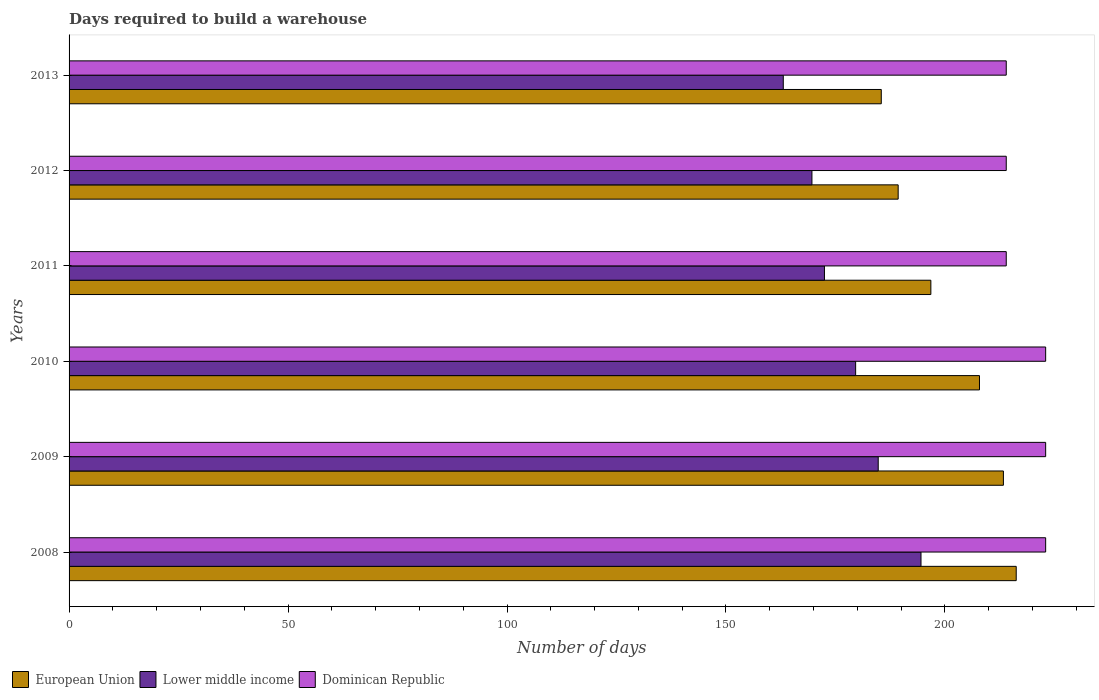How many different coloured bars are there?
Give a very brief answer. 3. In how many cases, is the number of bars for a given year not equal to the number of legend labels?
Make the answer very short. 0. What is the days required to build a warehouse in in European Union in 2011?
Your response must be concise. 196.79. Across all years, what is the maximum days required to build a warehouse in in Dominican Republic?
Make the answer very short. 223. Across all years, what is the minimum days required to build a warehouse in in Dominican Republic?
Ensure brevity in your answer.  214. In which year was the days required to build a warehouse in in Dominican Republic maximum?
Your answer should be very brief. 2008. What is the total days required to build a warehouse in in Lower middle income in the graph?
Keep it short and to the point. 1064.12. What is the difference between the days required to build a warehouse in in Dominican Republic in 2010 and that in 2012?
Your answer should be compact. 9. What is the difference between the days required to build a warehouse in in Dominican Republic in 2009 and the days required to build a warehouse in in Lower middle income in 2008?
Provide a short and direct response. 28.47. What is the average days required to build a warehouse in in Dominican Republic per year?
Offer a very short reply. 218.5. In the year 2009, what is the difference between the days required to build a warehouse in in Dominican Republic and days required to build a warehouse in in European Union?
Your answer should be compact. 9.65. What is the ratio of the days required to build a warehouse in in Dominican Republic in 2008 to that in 2010?
Offer a very short reply. 1. What is the difference between the highest and the second highest days required to build a warehouse in in European Union?
Your answer should be compact. 2.93. What is the difference between the highest and the lowest days required to build a warehouse in in European Union?
Provide a short and direct response. 30.81. Is the sum of the days required to build a warehouse in in European Union in 2010 and 2011 greater than the maximum days required to build a warehouse in in Lower middle income across all years?
Your answer should be very brief. Yes. What does the 2nd bar from the top in 2009 represents?
Offer a very short reply. Lower middle income. What does the 1st bar from the bottom in 2012 represents?
Your response must be concise. European Union. Is it the case that in every year, the sum of the days required to build a warehouse in in European Union and days required to build a warehouse in in Dominican Republic is greater than the days required to build a warehouse in in Lower middle income?
Make the answer very short. Yes. How many bars are there?
Provide a succinct answer. 18. Are all the bars in the graph horizontal?
Ensure brevity in your answer.  Yes. What is the difference between two consecutive major ticks on the X-axis?
Provide a succinct answer. 50. Where does the legend appear in the graph?
Ensure brevity in your answer.  Bottom left. How are the legend labels stacked?
Ensure brevity in your answer.  Horizontal. What is the title of the graph?
Make the answer very short. Days required to build a warehouse. Does "Cote d'Ivoire" appear as one of the legend labels in the graph?
Your answer should be compact. No. What is the label or title of the X-axis?
Ensure brevity in your answer.  Number of days. What is the Number of days of European Union in 2008?
Your response must be concise. 216.28. What is the Number of days in Lower middle income in 2008?
Keep it short and to the point. 194.53. What is the Number of days of Dominican Republic in 2008?
Give a very brief answer. 223. What is the Number of days in European Union in 2009?
Your response must be concise. 213.35. What is the Number of days of Lower middle income in 2009?
Make the answer very short. 184.77. What is the Number of days of Dominican Republic in 2009?
Ensure brevity in your answer.  223. What is the Number of days in European Union in 2010?
Make the answer very short. 207.89. What is the Number of days of Lower middle income in 2010?
Offer a terse response. 179.61. What is the Number of days in Dominican Republic in 2010?
Give a very brief answer. 223. What is the Number of days of European Union in 2011?
Your answer should be very brief. 196.79. What is the Number of days of Lower middle income in 2011?
Your answer should be very brief. 172.49. What is the Number of days in Dominican Republic in 2011?
Offer a terse response. 214. What is the Number of days in European Union in 2012?
Ensure brevity in your answer.  189.32. What is the Number of days in Lower middle income in 2012?
Offer a terse response. 169.63. What is the Number of days in Dominican Republic in 2012?
Your answer should be compact. 214. What is the Number of days in European Union in 2013?
Offer a very short reply. 185.46. What is the Number of days in Lower middle income in 2013?
Offer a very short reply. 163.09. What is the Number of days in Dominican Republic in 2013?
Keep it short and to the point. 214. Across all years, what is the maximum Number of days in European Union?
Your answer should be compact. 216.28. Across all years, what is the maximum Number of days in Lower middle income?
Provide a short and direct response. 194.53. Across all years, what is the maximum Number of days of Dominican Republic?
Your answer should be very brief. 223. Across all years, what is the minimum Number of days of European Union?
Offer a very short reply. 185.46. Across all years, what is the minimum Number of days in Lower middle income?
Keep it short and to the point. 163.09. Across all years, what is the minimum Number of days of Dominican Republic?
Keep it short and to the point. 214. What is the total Number of days of European Union in the graph?
Keep it short and to the point. 1209.09. What is the total Number of days of Lower middle income in the graph?
Make the answer very short. 1064.12. What is the total Number of days in Dominican Republic in the graph?
Provide a succinct answer. 1311. What is the difference between the Number of days of European Union in 2008 and that in 2009?
Give a very brief answer. 2.93. What is the difference between the Number of days of Lower middle income in 2008 and that in 2009?
Offer a very short reply. 9.77. What is the difference between the Number of days in Dominican Republic in 2008 and that in 2009?
Give a very brief answer. 0. What is the difference between the Number of days in European Union in 2008 and that in 2010?
Your answer should be very brief. 8.39. What is the difference between the Number of days in Lower middle income in 2008 and that in 2010?
Keep it short and to the point. 14.92. What is the difference between the Number of days in Dominican Republic in 2008 and that in 2010?
Give a very brief answer. 0. What is the difference between the Number of days of European Union in 2008 and that in 2011?
Provide a succinct answer. 19.49. What is the difference between the Number of days in Lower middle income in 2008 and that in 2011?
Offer a very short reply. 22.05. What is the difference between the Number of days of European Union in 2008 and that in 2012?
Make the answer very short. 26.96. What is the difference between the Number of days in Lower middle income in 2008 and that in 2012?
Your answer should be very brief. 24.9. What is the difference between the Number of days in Dominican Republic in 2008 and that in 2012?
Provide a succinct answer. 9. What is the difference between the Number of days of European Union in 2008 and that in 2013?
Make the answer very short. 30.81. What is the difference between the Number of days of Lower middle income in 2008 and that in 2013?
Make the answer very short. 31.45. What is the difference between the Number of days in Dominican Republic in 2008 and that in 2013?
Offer a terse response. 9. What is the difference between the Number of days of European Union in 2009 and that in 2010?
Offer a terse response. 5.46. What is the difference between the Number of days in Lower middle income in 2009 and that in 2010?
Offer a terse response. 5.16. What is the difference between the Number of days in Dominican Republic in 2009 and that in 2010?
Offer a very short reply. 0. What is the difference between the Number of days of European Union in 2009 and that in 2011?
Keep it short and to the point. 16.57. What is the difference between the Number of days in Lower middle income in 2009 and that in 2011?
Keep it short and to the point. 12.28. What is the difference between the Number of days in Dominican Republic in 2009 and that in 2011?
Offer a terse response. 9. What is the difference between the Number of days in European Union in 2009 and that in 2012?
Your answer should be very brief. 24.03. What is the difference between the Number of days of Lower middle income in 2009 and that in 2012?
Keep it short and to the point. 15.14. What is the difference between the Number of days in Dominican Republic in 2009 and that in 2012?
Ensure brevity in your answer.  9. What is the difference between the Number of days in European Union in 2009 and that in 2013?
Offer a terse response. 27.89. What is the difference between the Number of days in Lower middle income in 2009 and that in 2013?
Your answer should be compact. 21.68. What is the difference between the Number of days of Dominican Republic in 2009 and that in 2013?
Provide a succinct answer. 9. What is the difference between the Number of days in European Union in 2010 and that in 2011?
Your answer should be very brief. 11.1. What is the difference between the Number of days of Lower middle income in 2010 and that in 2011?
Your response must be concise. 7.12. What is the difference between the Number of days of European Union in 2010 and that in 2012?
Your answer should be very brief. 18.57. What is the difference between the Number of days of Lower middle income in 2010 and that in 2012?
Provide a short and direct response. 9.98. What is the difference between the Number of days in Dominican Republic in 2010 and that in 2012?
Provide a short and direct response. 9. What is the difference between the Number of days in European Union in 2010 and that in 2013?
Your answer should be very brief. 22.42. What is the difference between the Number of days of Lower middle income in 2010 and that in 2013?
Offer a terse response. 16.52. What is the difference between the Number of days in Dominican Republic in 2010 and that in 2013?
Provide a short and direct response. 9. What is the difference between the Number of days in European Union in 2011 and that in 2012?
Your response must be concise. 7.46. What is the difference between the Number of days in Lower middle income in 2011 and that in 2012?
Offer a terse response. 2.86. What is the difference between the Number of days of Dominican Republic in 2011 and that in 2012?
Provide a succinct answer. 0. What is the difference between the Number of days of European Union in 2011 and that in 2013?
Offer a very short reply. 11.32. What is the difference between the Number of days in Lower middle income in 2011 and that in 2013?
Give a very brief answer. 9.4. What is the difference between the Number of days of European Union in 2012 and that in 2013?
Your response must be concise. 3.86. What is the difference between the Number of days in Lower middle income in 2012 and that in 2013?
Ensure brevity in your answer.  6.54. What is the difference between the Number of days of European Union in 2008 and the Number of days of Lower middle income in 2009?
Offer a terse response. 31.51. What is the difference between the Number of days in European Union in 2008 and the Number of days in Dominican Republic in 2009?
Offer a terse response. -6.72. What is the difference between the Number of days in Lower middle income in 2008 and the Number of days in Dominican Republic in 2009?
Offer a very short reply. -28.47. What is the difference between the Number of days in European Union in 2008 and the Number of days in Lower middle income in 2010?
Offer a very short reply. 36.67. What is the difference between the Number of days of European Union in 2008 and the Number of days of Dominican Republic in 2010?
Offer a very short reply. -6.72. What is the difference between the Number of days of Lower middle income in 2008 and the Number of days of Dominican Republic in 2010?
Keep it short and to the point. -28.47. What is the difference between the Number of days of European Union in 2008 and the Number of days of Lower middle income in 2011?
Give a very brief answer. 43.79. What is the difference between the Number of days of European Union in 2008 and the Number of days of Dominican Republic in 2011?
Your answer should be very brief. 2.28. What is the difference between the Number of days in Lower middle income in 2008 and the Number of days in Dominican Republic in 2011?
Offer a terse response. -19.47. What is the difference between the Number of days of European Union in 2008 and the Number of days of Lower middle income in 2012?
Your answer should be very brief. 46.65. What is the difference between the Number of days in European Union in 2008 and the Number of days in Dominican Republic in 2012?
Provide a succinct answer. 2.28. What is the difference between the Number of days of Lower middle income in 2008 and the Number of days of Dominican Republic in 2012?
Make the answer very short. -19.47. What is the difference between the Number of days of European Union in 2008 and the Number of days of Lower middle income in 2013?
Your answer should be compact. 53.19. What is the difference between the Number of days in European Union in 2008 and the Number of days in Dominican Republic in 2013?
Offer a very short reply. 2.28. What is the difference between the Number of days in Lower middle income in 2008 and the Number of days in Dominican Republic in 2013?
Offer a very short reply. -19.47. What is the difference between the Number of days of European Union in 2009 and the Number of days of Lower middle income in 2010?
Make the answer very short. 33.74. What is the difference between the Number of days of European Union in 2009 and the Number of days of Dominican Republic in 2010?
Keep it short and to the point. -9.65. What is the difference between the Number of days in Lower middle income in 2009 and the Number of days in Dominican Republic in 2010?
Give a very brief answer. -38.23. What is the difference between the Number of days in European Union in 2009 and the Number of days in Lower middle income in 2011?
Give a very brief answer. 40.86. What is the difference between the Number of days of European Union in 2009 and the Number of days of Dominican Republic in 2011?
Keep it short and to the point. -0.65. What is the difference between the Number of days of Lower middle income in 2009 and the Number of days of Dominican Republic in 2011?
Offer a terse response. -29.23. What is the difference between the Number of days in European Union in 2009 and the Number of days in Lower middle income in 2012?
Ensure brevity in your answer.  43.72. What is the difference between the Number of days of European Union in 2009 and the Number of days of Dominican Republic in 2012?
Offer a very short reply. -0.65. What is the difference between the Number of days in Lower middle income in 2009 and the Number of days in Dominican Republic in 2012?
Your answer should be compact. -29.23. What is the difference between the Number of days in European Union in 2009 and the Number of days in Lower middle income in 2013?
Provide a succinct answer. 50.26. What is the difference between the Number of days of European Union in 2009 and the Number of days of Dominican Republic in 2013?
Your response must be concise. -0.65. What is the difference between the Number of days in Lower middle income in 2009 and the Number of days in Dominican Republic in 2013?
Your answer should be very brief. -29.23. What is the difference between the Number of days in European Union in 2010 and the Number of days in Lower middle income in 2011?
Make the answer very short. 35.4. What is the difference between the Number of days in European Union in 2010 and the Number of days in Dominican Republic in 2011?
Offer a very short reply. -6.11. What is the difference between the Number of days of Lower middle income in 2010 and the Number of days of Dominican Republic in 2011?
Provide a succinct answer. -34.39. What is the difference between the Number of days of European Union in 2010 and the Number of days of Lower middle income in 2012?
Provide a short and direct response. 38.26. What is the difference between the Number of days in European Union in 2010 and the Number of days in Dominican Republic in 2012?
Your response must be concise. -6.11. What is the difference between the Number of days in Lower middle income in 2010 and the Number of days in Dominican Republic in 2012?
Your answer should be very brief. -34.39. What is the difference between the Number of days of European Union in 2010 and the Number of days of Lower middle income in 2013?
Your answer should be compact. 44.8. What is the difference between the Number of days in European Union in 2010 and the Number of days in Dominican Republic in 2013?
Give a very brief answer. -6.11. What is the difference between the Number of days of Lower middle income in 2010 and the Number of days of Dominican Republic in 2013?
Provide a succinct answer. -34.39. What is the difference between the Number of days in European Union in 2011 and the Number of days in Lower middle income in 2012?
Your answer should be very brief. 27.16. What is the difference between the Number of days in European Union in 2011 and the Number of days in Dominican Republic in 2012?
Offer a terse response. -17.21. What is the difference between the Number of days in Lower middle income in 2011 and the Number of days in Dominican Republic in 2012?
Provide a succinct answer. -41.51. What is the difference between the Number of days in European Union in 2011 and the Number of days in Lower middle income in 2013?
Make the answer very short. 33.7. What is the difference between the Number of days in European Union in 2011 and the Number of days in Dominican Republic in 2013?
Offer a very short reply. -17.21. What is the difference between the Number of days in Lower middle income in 2011 and the Number of days in Dominican Republic in 2013?
Offer a very short reply. -41.51. What is the difference between the Number of days of European Union in 2012 and the Number of days of Lower middle income in 2013?
Offer a very short reply. 26.23. What is the difference between the Number of days in European Union in 2012 and the Number of days in Dominican Republic in 2013?
Keep it short and to the point. -24.68. What is the difference between the Number of days of Lower middle income in 2012 and the Number of days of Dominican Republic in 2013?
Give a very brief answer. -44.37. What is the average Number of days in European Union per year?
Your answer should be very brief. 201.51. What is the average Number of days of Lower middle income per year?
Provide a succinct answer. 177.35. What is the average Number of days in Dominican Republic per year?
Offer a terse response. 218.5. In the year 2008, what is the difference between the Number of days of European Union and Number of days of Lower middle income?
Give a very brief answer. 21.74. In the year 2008, what is the difference between the Number of days of European Union and Number of days of Dominican Republic?
Provide a short and direct response. -6.72. In the year 2008, what is the difference between the Number of days in Lower middle income and Number of days in Dominican Republic?
Your answer should be compact. -28.47. In the year 2009, what is the difference between the Number of days in European Union and Number of days in Lower middle income?
Your answer should be very brief. 28.59. In the year 2009, what is the difference between the Number of days of European Union and Number of days of Dominican Republic?
Your answer should be very brief. -9.65. In the year 2009, what is the difference between the Number of days of Lower middle income and Number of days of Dominican Republic?
Offer a terse response. -38.23. In the year 2010, what is the difference between the Number of days in European Union and Number of days in Lower middle income?
Your answer should be very brief. 28.28. In the year 2010, what is the difference between the Number of days of European Union and Number of days of Dominican Republic?
Your answer should be very brief. -15.11. In the year 2010, what is the difference between the Number of days in Lower middle income and Number of days in Dominican Republic?
Ensure brevity in your answer.  -43.39. In the year 2011, what is the difference between the Number of days in European Union and Number of days in Lower middle income?
Offer a terse response. 24.3. In the year 2011, what is the difference between the Number of days of European Union and Number of days of Dominican Republic?
Your answer should be compact. -17.21. In the year 2011, what is the difference between the Number of days of Lower middle income and Number of days of Dominican Republic?
Offer a terse response. -41.51. In the year 2012, what is the difference between the Number of days in European Union and Number of days in Lower middle income?
Keep it short and to the point. 19.69. In the year 2012, what is the difference between the Number of days in European Union and Number of days in Dominican Republic?
Give a very brief answer. -24.68. In the year 2012, what is the difference between the Number of days of Lower middle income and Number of days of Dominican Republic?
Provide a short and direct response. -44.37. In the year 2013, what is the difference between the Number of days of European Union and Number of days of Lower middle income?
Provide a short and direct response. 22.38. In the year 2013, what is the difference between the Number of days of European Union and Number of days of Dominican Republic?
Ensure brevity in your answer.  -28.54. In the year 2013, what is the difference between the Number of days in Lower middle income and Number of days in Dominican Republic?
Ensure brevity in your answer.  -50.91. What is the ratio of the Number of days of European Union in 2008 to that in 2009?
Your answer should be very brief. 1.01. What is the ratio of the Number of days in Lower middle income in 2008 to that in 2009?
Offer a terse response. 1.05. What is the ratio of the Number of days in Dominican Republic in 2008 to that in 2009?
Make the answer very short. 1. What is the ratio of the Number of days of European Union in 2008 to that in 2010?
Provide a succinct answer. 1.04. What is the ratio of the Number of days in Lower middle income in 2008 to that in 2010?
Your answer should be very brief. 1.08. What is the ratio of the Number of days of Dominican Republic in 2008 to that in 2010?
Your response must be concise. 1. What is the ratio of the Number of days in European Union in 2008 to that in 2011?
Offer a very short reply. 1.1. What is the ratio of the Number of days of Lower middle income in 2008 to that in 2011?
Ensure brevity in your answer.  1.13. What is the ratio of the Number of days in Dominican Republic in 2008 to that in 2011?
Make the answer very short. 1.04. What is the ratio of the Number of days of European Union in 2008 to that in 2012?
Make the answer very short. 1.14. What is the ratio of the Number of days of Lower middle income in 2008 to that in 2012?
Your response must be concise. 1.15. What is the ratio of the Number of days of Dominican Republic in 2008 to that in 2012?
Give a very brief answer. 1.04. What is the ratio of the Number of days of European Union in 2008 to that in 2013?
Provide a short and direct response. 1.17. What is the ratio of the Number of days of Lower middle income in 2008 to that in 2013?
Your answer should be compact. 1.19. What is the ratio of the Number of days in Dominican Republic in 2008 to that in 2013?
Ensure brevity in your answer.  1.04. What is the ratio of the Number of days of European Union in 2009 to that in 2010?
Keep it short and to the point. 1.03. What is the ratio of the Number of days of Lower middle income in 2009 to that in 2010?
Your answer should be compact. 1.03. What is the ratio of the Number of days in European Union in 2009 to that in 2011?
Offer a terse response. 1.08. What is the ratio of the Number of days of Lower middle income in 2009 to that in 2011?
Keep it short and to the point. 1.07. What is the ratio of the Number of days of Dominican Republic in 2009 to that in 2011?
Ensure brevity in your answer.  1.04. What is the ratio of the Number of days in European Union in 2009 to that in 2012?
Make the answer very short. 1.13. What is the ratio of the Number of days of Lower middle income in 2009 to that in 2012?
Offer a terse response. 1.09. What is the ratio of the Number of days in Dominican Republic in 2009 to that in 2012?
Offer a terse response. 1.04. What is the ratio of the Number of days in European Union in 2009 to that in 2013?
Provide a short and direct response. 1.15. What is the ratio of the Number of days in Lower middle income in 2009 to that in 2013?
Offer a terse response. 1.13. What is the ratio of the Number of days in Dominican Republic in 2009 to that in 2013?
Make the answer very short. 1.04. What is the ratio of the Number of days in European Union in 2010 to that in 2011?
Provide a short and direct response. 1.06. What is the ratio of the Number of days of Lower middle income in 2010 to that in 2011?
Offer a terse response. 1.04. What is the ratio of the Number of days in Dominican Republic in 2010 to that in 2011?
Your answer should be very brief. 1.04. What is the ratio of the Number of days of European Union in 2010 to that in 2012?
Provide a succinct answer. 1.1. What is the ratio of the Number of days of Lower middle income in 2010 to that in 2012?
Offer a very short reply. 1.06. What is the ratio of the Number of days in Dominican Republic in 2010 to that in 2012?
Your response must be concise. 1.04. What is the ratio of the Number of days of European Union in 2010 to that in 2013?
Provide a short and direct response. 1.12. What is the ratio of the Number of days in Lower middle income in 2010 to that in 2013?
Make the answer very short. 1.1. What is the ratio of the Number of days in Dominican Republic in 2010 to that in 2013?
Offer a terse response. 1.04. What is the ratio of the Number of days of European Union in 2011 to that in 2012?
Give a very brief answer. 1.04. What is the ratio of the Number of days of Lower middle income in 2011 to that in 2012?
Keep it short and to the point. 1.02. What is the ratio of the Number of days of Dominican Republic in 2011 to that in 2012?
Your answer should be compact. 1. What is the ratio of the Number of days of European Union in 2011 to that in 2013?
Ensure brevity in your answer.  1.06. What is the ratio of the Number of days of Lower middle income in 2011 to that in 2013?
Give a very brief answer. 1.06. What is the ratio of the Number of days in European Union in 2012 to that in 2013?
Provide a short and direct response. 1.02. What is the ratio of the Number of days of Lower middle income in 2012 to that in 2013?
Offer a very short reply. 1.04. What is the difference between the highest and the second highest Number of days of European Union?
Your response must be concise. 2.93. What is the difference between the highest and the second highest Number of days of Lower middle income?
Offer a terse response. 9.77. What is the difference between the highest and the lowest Number of days in European Union?
Make the answer very short. 30.81. What is the difference between the highest and the lowest Number of days of Lower middle income?
Give a very brief answer. 31.45. What is the difference between the highest and the lowest Number of days of Dominican Republic?
Provide a short and direct response. 9. 